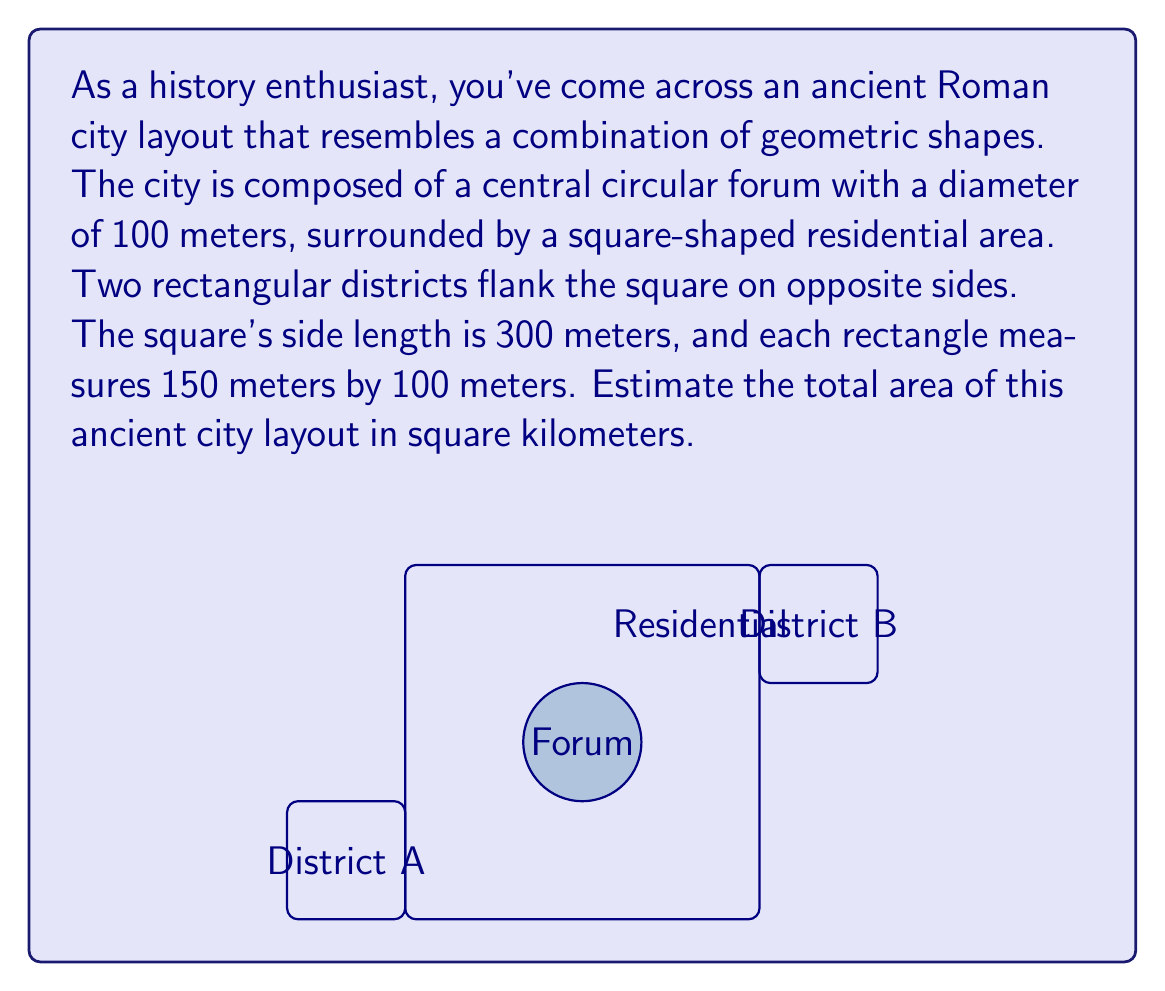Could you help me with this problem? Let's break this down step-by-step:

1) Area of the circular forum:
   $A_{circle} = \pi r^2 = \pi (50\text{ m})^2 = 7,853.98\text{ m}^2$

2) Area of the square residential area:
   $A_{square} = s^2 = (300\text{ m})^2 = 90,000\text{ m}^2$

3) Area of each rectangular district:
   $A_{rectangle} = l \times w = 150\text{ m} \times 100\text{ m} = 15,000\text{ m}^2$

4) Total area of both rectangular districts:
   $A_{rectangles} = 2 \times 15,000\text{ m}^2 = 30,000\text{ m}^2$

5) Total area of the city:
   $A_{total} = A_{circle} + A_{square} + A_{rectangles}$
   $A_{total} = 7,853.98 + 90,000 + 30,000 = 127,853.98\text{ m}^2$

6) Convert to square kilometers:
   $127,853.98\text{ m}^2 = 0.12785398\text{ km}^2$

Rounding to a reasonable precision for an estimate, we get 0.128 km².
Answer: 0.128 km² 